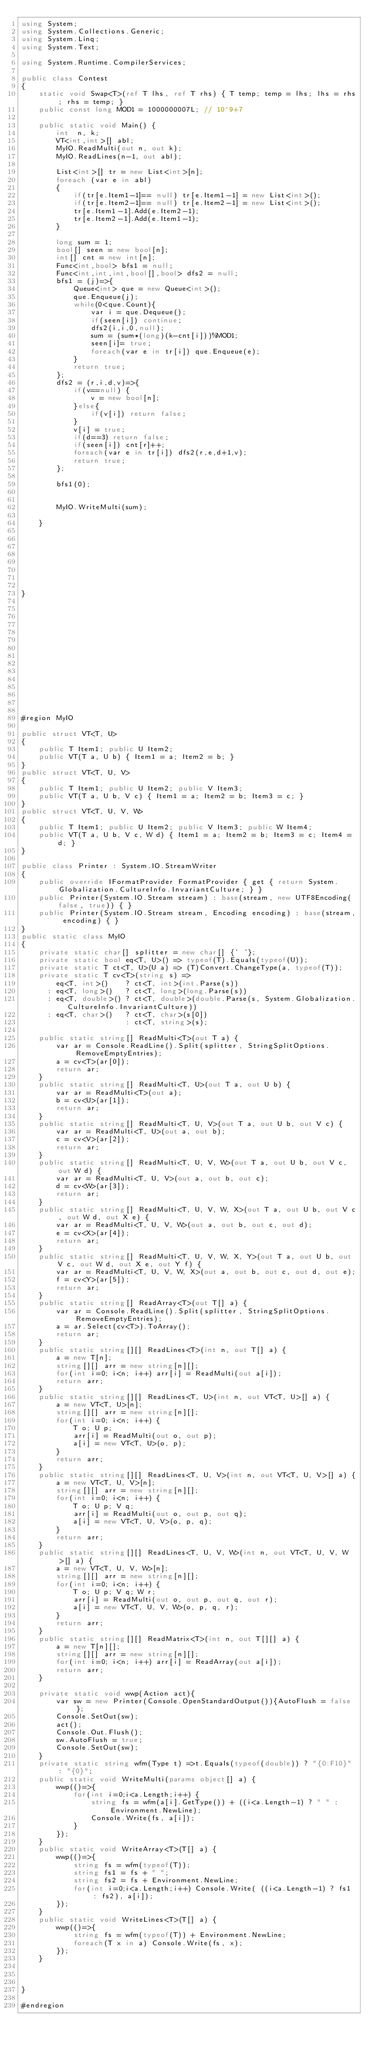Convert code to text. <code><loc_0><loc_0><loc_500><loc_500><_C#_>using System;
using System.Collections.Generic;
using System.Linq;
using System.Text;

using System.Runtime.CompilerServices;

public class Contest
{
	static void Swap<T>(ref T lhs, ref T rhs) { T temp; temp = lhs; lhs = rhs; rhs = temp; }
	public const long MOD1 = 1000000007L; // 10^9+7

	public static void Main() {
		int  n, k;
		VT<int,int>[] abl;
		MyIO.ReadMulti(out n, out k);
		MyIO.ReadLines(n-1, out abl);

		List<int>[] tr = new List<int>[n];
		foreach (var e in abl)
		{
			if(tr[e.Item1-1]== null) tr[e.Item1-1] = new List<int>();
			if(tr[e.Item2-1]== null) tr[e.Item2-1] = new List<int>();
			tr[e.Item1-1].Add(e.Item2-1);
			tr[e.Item2-1].Add(e.Item1-1);
		}

		long sum = 1;
		bool[] seen = new bool[n];
		int[] cnt = new int[n];
		Func<int,bool> bfs1 = null;
		Func<int,int,int,bool[],bool> dfs2 = null;
		bfs1 = (j)=>{
			Queue<int> que = new Queue<int>();
			que.Enqueue(j);
			while(0<que.Count){
				var i = que.Dequeue();
				if(seen[i]) continue;
				dfs2(i,i,0,null);
				sum = (sum*(long)(k-cnt[i]))%MOD1;
				seen[i]= true;
				foreach(var e in tr[i]) que.Enqueue(e);
			}
			return true;
		};
		dfs2 = (r,i,d,v)=>{
			if(v==null) { 
				v = new bool[n];
			}else{
				if(v[i]) return false;
			}
			v[i] = true;
			if(d==3) return false;
			if(seen[i]) cnt[r]++;
			foreach(var e in tr[i]) dfs2(r,e,d+1,v);
			return true;
		};

		bfs1(0);


		MyIO.WriteMulti(sum);

	}








}















#region MyIO

public struct VT<T, U>
{
	public T Item1; public U Item2;
    public VT(T a, U b) { Item1 = a; Item2 = b; }
}
public struct VT<T, U, V>
{
	public T Item1; public U Item2; public V Item3;
    public VT(T a, U b, V c) { Item1 = a; Item2 = b; Item3 = c; }
}
public struct VT<T, U, V, W>
{
	public T Item1; public U Item2; public V Item3; public W Item4;
    public VT(T a, U b, V c, W d) { Item1 = a; Item2 = b; Item3 = c; Item4 = d; }
}

public class Printer : System.IO.StreamWriter
{
	public override IFormatProvider FormatProvider { get { return System.Globalization.CultureInfo.InvariantCulture; } }
	public Printer(System.IO.Stream stream) : base(stream, new UTF8Encoding(false, true)) { }
	public Printer(System.IO.Stream stream, Encoding encoding) : base(stream, encoding) { }
}
public static class MyIO
{
	private static char[] splitter = new char[] {' '};
	private static bool eq<T, U>() => typeof(T).Equals(typeof(U));
	private static T ct<T, U>(U a) => (T)Convert.ChangeType(a, typeof(T));
	private static T cv<T>(string s) =>
		eq<T, int>()    ? ct<T, int>(int.Parse(s))
	  : eq<T, long>()   ? ct<T, long>(long.Parse(s))
	  : eq<T, double>() ? ct<T, double>(double.Parse(s, System.Globalization.CultureInfo.InvariantCulture))
	  : eq<T, char>()   ? ct<T, char>(s[0])
						: ct<T, string>(s);
			
	public static string[] ReadMulti<T>(out T a) {
		var ar = Console.ReadLine().Split(splitter, StringSplitOptions.RemoveEmptyEntries); 
		a = cv<T>(ar[0]);
		return ar;
	}
	public static string[] ReadMulti<T, U>(out T a, out U b) {
		var ar = ReadMulti<T>(out a); 
        b = cv<U>(ar[1]);
		return ar;
	}
	public static string[] ReadMulti<T, U, V>(out T a, out U b, out V c) {
		var ar = ReadMulti<T, U>(out a, out b); 
        c = cv<V>(ar[2]);
		return ar;
	}
	public static string[] ReadMulti<T, U, V, W>(out T a, out U b, out V c, out W d) {
		var ar = ReadMulti<T, U, V>(out a, out b, out c); 
        d = cv<W>(ar[3]);
		return ar;
	}
	public static string[] ReadMulti<T, U, V, W, X>(out T a, out U b, out V c, out W d, out X e) {
		var ar = ReadMulti<T, U, V, W>(out a, out b, out c, out d); 
        e = cv<X>(ar[4]);
		return ar;
	}
	public static string[] ReadMulti<T, U, V, W, X, Y>(out T a, out U b, out V c, out W d, out X e, out Y f) {
		var ar = ReadMulti<T, U, V, W, X>(out a, out b, out c, out d, out e); 
        f = cv<Y>(ar[5]);
		return ar;
	}
	public static string[] ReadArray<T>(out T[] a) {		
		var ar = Console.ReadLine().Split(splitter, StringSplitOptions.RemoveEmptyEntries);
		a = ar.Select(cv<T>).ToArray();
		return ar;
	}		
	public static string[][] ReadLines<T>(int n, out T[] a) {
		a = new T[n];
		string[][] arr = new string[n][];
		for(int i=0; i<n; i++) arr[i] = ReadMulti(out a[i]);
		return arr;
	}
	public static string[][] ReadLines<T, U>(int n, out VT<T, U>[] a) {
		a = new VT<T, U>[n];
		string[][] arr = new string[n][];
		for(int i=0; i<n; i++) {
			T o; U p;
			arr[i] = ReadMulti(out o, out p);
			a[i] = new VT<T, U>(o, p);
		}
		return arr;
	}
	public static string[][] ReadLines<T, U, V>(int n, out VT<T, U, V>[] a) {
		a = new VT<T, U, V>[n];
		string[][] arr = new string[n][];
		for(int i=0; i<n; i++) {
			T o; U p; V q;
			arr[i] = ReadMulti(out o, out p, out q);
			a[i] = new VT<T, U, V>(o, p, q);
		}
		return arr;
	}
	public static string[][] ReadLines<T, U, V, W>(int n, out VT<T, U, V, W>[] a) {
		a = new VT<T, U, V, W>[n];
		string[][] arr = new string[n][];
		for(int i=0; i<n; i++) {
			T o; U p; V q; W r;
			arr[i] = ReadMulti(out o, out p, out q, out r);
			a[i] = new VT<T, U, V, W>(o, p, q, r);
		}
		return arr;
	}
	public static string[][] ReadMatrix<T>(int n, out T[][] a) {
		a = new T[n][];
		string[][] arr = new string[n][];
		for(int i=0; i<n; i++) arr[i] = ReadArray(out a[i]);
		return arr;
	}

	private static void wwp(Action act){
		var sw = new Printer(Console.OpenStandardOutput()){AutoFlush = false};
		Console.SetOut(sw);
		act();
		Console.Out.Flush();
		sw.AutoFlush = true;
		Console.SetOut(sw);
	}
	private static string wfm(Type t) =>t.Equals(typeof(double)) ? "{0:F10}" : "{0}";
	public static void WriteMulti(params object[] a) {
		wwp(()=>{
			for(int i=0;i<a.Length;i++) {
				string fs = wfm(a[i].GetType()) + ((i<a.Length-1) ? " " : Environment.NewLine);
				Console.Write(fs, a[i]);
			}
		});
	}
	public static void WriteArray<T>(T[] a) {
		wwp(()=>{
			string fs = wfm(typeof(T));
			string fs1 = fs + " ";
			string fs2 = fs + Environment.NewLine;
			for(int i=0;i<a.Length;i++) Console.Write( ((i<a.Length-1) ? fs1 : fs2), a[i]);
		});
	}
	public static void WriteLines<T>(T[] a) {
		wwp(()=>{
			string fs = wfm(typeof(T)) + Environment.NewLine;
			foreach(T x in a) Console.Write(fs, x);
		});
	}



}

#endregion

</code> 